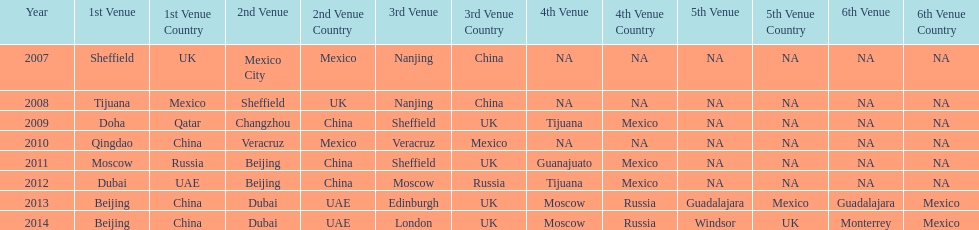In list of venues, how many years was beijing above moscow (1st venue is above 2nd venue, etc)? 3. 